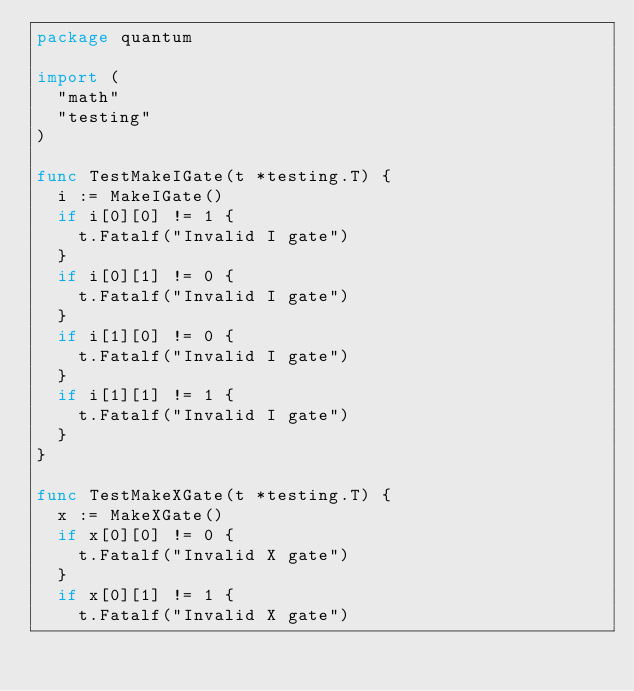<code> <loc_0><loc_0><loc_500><loc_500><_Go_>package quantum

import (
	"math"
	"testing"
)

func TestMakeIGate(t *testing.T) {
	i := MakeIGate()
	if i[0][0] != 1 {
		t.Fatalf("Invalid I gate")
	}
	if i[0][1] != 0 {
		t.Fatalf("Invalid I gate")
	}
	if i[1][0] != 0 {
		t.Fatalf("Invalid I gate")
	}
	if i[1][1] != 1 {
		t.Fatalf("Invalid I gate")
	}
}

func TestMakeXGate(t *testing.T) {
	x := MakeXGate()
	if x[0][0] != 0 {
		t.Fatalf("Invalid X gate")
	}
	if x[0][1] != 1 {
		t.Fatalf("Invalid X gate")</code> 